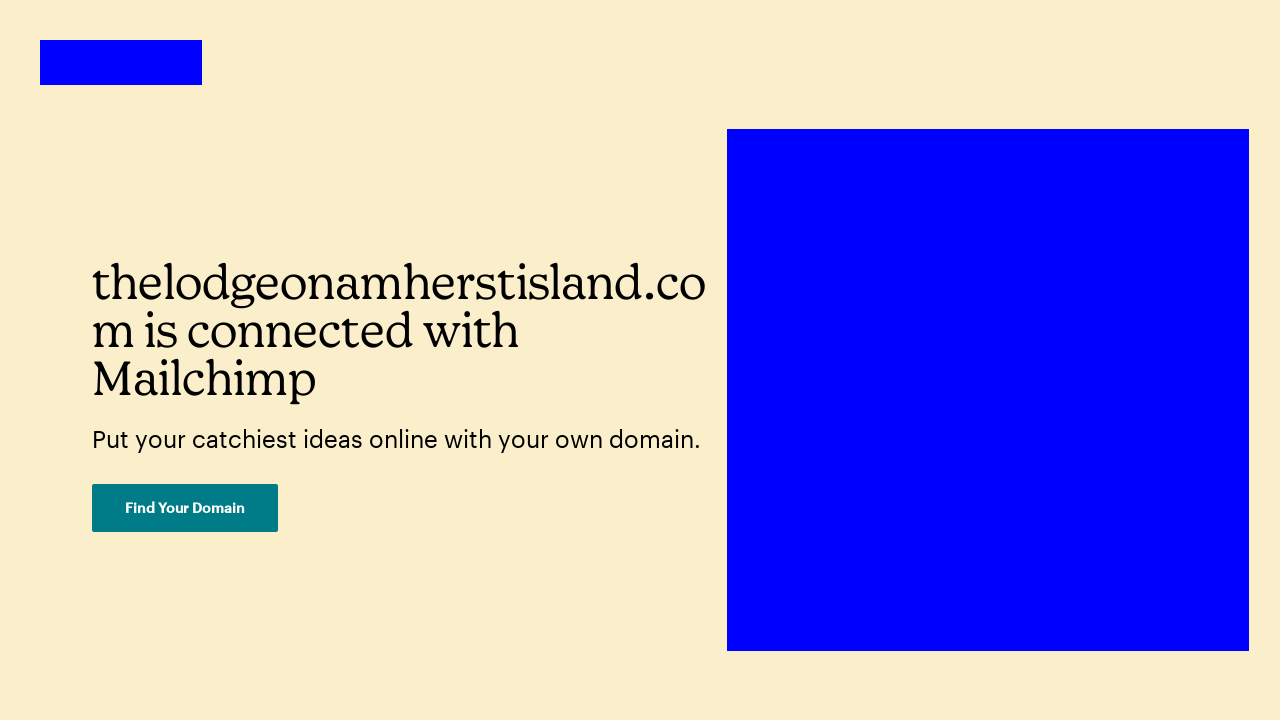What does the button labeled 'Find Your Domain' imply about the functionality of the website? The 'Find Your Domain' button implies that the website offers services related to domain registration or management. It suggests that users can search for and possibly purchase or manage domain names directly through this website, likely aimed at individuals or businesses wanting to establish an online presence. 